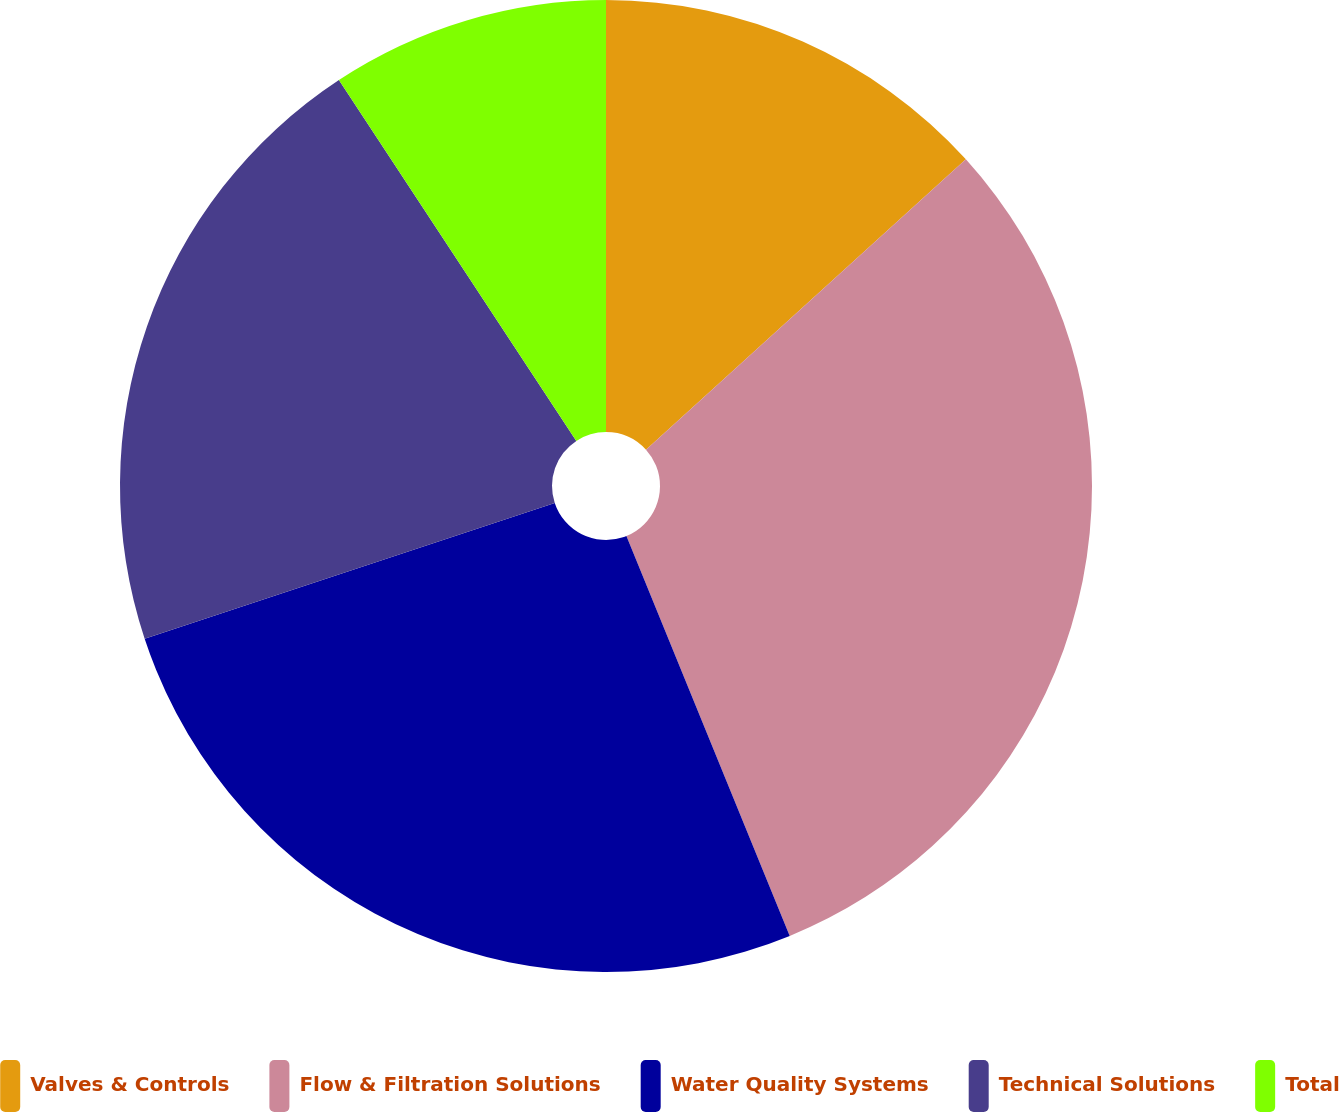Convert chart. <chart><loc_0><loc_0><loc_500><loc_500><pie_chart><fcel>Valves & Controls<fcel>Flow & Filtration Solutions<fcel>Water Quality Systems<fcel>Technical Solutions<fcel>Total<nl><fcel>13.27%<fcel>30.56%<fcel>26.08%<fcel>20.83%<fcel>9.26%<nl></chart> 